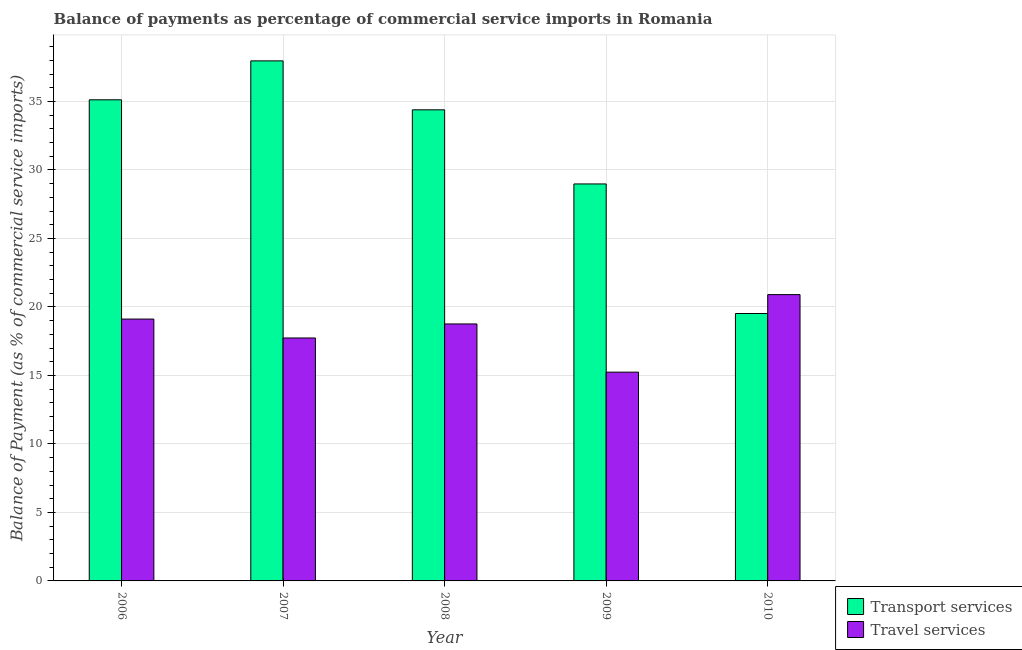How many different coloured bars are there?
Provide a succinct answer. 2. Are the number of bars per tick equal to the number of legend labels?
Provide a succinct answer. Yes. How many bars are there on the 1st tick from the right?
Your answer should be very brief. 2. What is the balance of payments of travel services in 2006?
Give a very brief answer. 19.11. Across all years, what is the maximum balance of payments of transport services?
Your answer should be very brief. 37.96. Across all years, what is the minimum balance of payments of travel services?
Your answer should be very brief. 15.24. In which year was the balance of payments of transport services maximum?
Ensure brevity in your answer.  2007. What is the total balance of payments of transport services in the graph?
Your response must be concise. 155.97. What is the difference between the balance of payments of travel services in 2006 and that in 2008?
Provide a succinct answer. 0.36. What is the difference between the balance of payments of travel services in 2006 and the balance of payments of transport services in 2008?
Your answer should be very brief. 0.36. What is the average balance of payments of travel services per year?
Offer a very short reply. 18.35. What is the ratio of the balance of payments of travel services in 2006 to that in 2009?
Offer a very short reply. 1.25. Is the balance of payments of transport services in 2006 less than that in 2009?
Provide a succinct answer. No. What is the difference between the highest and the second highest balance of payments of transport services?
Offer a terse response. 2.84. What is the difference between the highest and the lowest balance of payments of travel services?
Your answer should be very brief. 5.66. Is the sum of the balance of payments of travel services in 2008 and 2010 greater than the maximum balance of payments of transport services across all years?
Ensure brevity in your answer.  Yes. What does the 2nd bar from the left in 2006 represents?
Your response must be concise. Travel services. What does the 2nd bar from the right in 2009 represents?
Provide a short and direct response. Transport services. How many bars are there?
Your response must be concise. 10. How many years are there in the graph?
Your answer should be very brief. 5. Are the values on the major ticks of Y-axis written in scientific E-notation?
Your answer should be very brief. No. Does the graph contain grids?
Provide a succinct answer. Yes. Where does the legend appear in the graph?
Provide a short and direct response. Bottom right. What is the title of the graph?
Give a very brief answer. Balance of payments as percentage of commercial service imports in Romania. What is the label or title of the Y-axis?
Offer a very short reply. Balance of Payment (as % of commercial service imports). What is the Balance of Payment (as % of commercial service imports) in Transport services in 2006?
Make the answer very short. 35.12. What is the Balance of Payment (as % of commercial service imports) of Travel services in 2006?
Ensure brevity in your answer.  19.11. What is the Balance of Payment (as % of commercial service imports) in Transport services in 2007?
Your response must be concise. 37.96. What is the Balance of Payment (as % of commercial service imports) in Travel services in 2007?
Make the answer very short. 17.73. What is the Balance of Payment (as % of commercial service imports) in Transport services in 2008?
Make the answer very short. 34.39. What is the Balance of Payment (as % of commercial service imports) in Travel services in 2008?
Make the answer very short. 18.76. What is the Balance of Payment (as % of commercial service imports) of Transport services in 2009?
Offer a very short reply. 28.98. What is the Balance of Payment (as % of commercial service imports) of Travel services in 2009?
Give a very brief answer. 15.24. What is the Balance of Payment (as % of commercial service imports) in Transport services in 2010?
Give a very brief answer. 19.52. What is the Balance of Payment (as % of commercial service imports) in Travel services in 2010?
Keep it short and to the point. 20.9. Across all years, what is the maximum Balance of Payment (as % of commercial service imports) in Transport services?
Keep it short and to the point. 37.96. Across all years, what is the maximum Balance of Payment (as % of commercial service imports) of Travel services?
Give a very brief answer. 20.9. Across all years, what is the minimum Balance of Payment (as % of commercial service imports) in Transport services?
Your answer should be very brief. 19.52. Across all years, what is the minimum Balance of Payment (as % of commercial service imports) of Travel services?
Your response must be concise. 15.24. What is the total Balance of Payment (as % of commercial service imports) of Transport services in the graph?
Make the answer very short. 155.97. What is the total Balance of Payment (as % of commercial service imports) in Travel services in the graph?
Provide a succinct answer. 91.75. What is the difference between the Balance of Payment (as % of commercial service imports) in Transport services in 2006 and that in 2007?
Offer a terse response. -2.84. What is the difference between the Balance of Payment (as % of commercial service imports) of Travel services in 2006 and that in 2007?
Provide a succinct answer. 1.38. What is the difference between the Balance of Payment (as % of commercial service imports) in Transport services in 2006 and that in 2008?
Your answer should be very brief. 0.73. What is the difference between the Balance of Payment (as % of commercial service imports) in Travel services in 2006 and that in 2008?
Offer a very short reply. 0.36. What is the difference between the Balance of Payment (as % of commercial service imports) in Transport services in 2006 and that in 2009?
Offer a very short reply. 6.14. What is the difference between the Balance of Payment (as % of commercial service imports) in Travel services in 2006 and that in 2009?
Provide a short and direct response. 3.87. What is the difference between the Balance of Payment (as % of commercial service imports) in Transport services in 2006 and that in 2010?
Offer a very short reply. 15.6. What is the difference between the Balance of Payment (as % of commercial service imports) of Travel services in 2006 and that in 2010?
Offer a terse response. -1.79. What is the difference between the Balance of Payment (as % of commercial service imports) in Transport services in 2007 and that in 2008?
Provide a short and direct response. 3.57. What is the difference between the Balance of Payment (as % of commercial service imports) in Travel services in 2007 and that in 2008?
Provide a succinct answer. -1.02. What is the difference between the Balance of Payment (as % of commercial service imports) of Transport services in 2007 and that in 2009?
Provide a succinct answer. 8.98. What is the difference between the Balance of Payment (as % of commercial service imports) of Travel services in 2007 and that in 2009?
Your answer should be compact. 2.49. What is the difference between the Balance of Payment (as % of commercial service imports) in Transport services in 2007 and that in 2010?
Keep it short and to the point. 18.44. What is the difference between the Balance of Payment (as % of commercial service imports) of Travel services in 2007 and that in 2010?
Keep it short and to the point. -3.17. What is the difference between the Balance of Payment (as % of commercial service imports) of Transport services in 2008 and that in 2009?
Make the answer very short. 5.41. What is the difference between the Balance of Payment (as % of commercial service imports) in Travel services in 2008 and that in 2009?
Offer a very short reply. 3.52. What is the difference between the Balance of Payment (as % of commercial service imports) of Transport services in 2008 and that in 2010?
Offer a very short reply. 14.87. What is the difference between the Balance of Payment (as % of commercial service imports) in Travel services in 2008 and that in 2010?
Ensure brevity in your answer.  -2.14. What is the difference between the Balance of Payment (as % of commercial service imports) of Transport services in 2009 and that in 2010?
Your answer should be compact. 9.46. What is the difference between the Balance of Payment (as % of commercial service imports) in Travel services in 2009 and that in 2010?
Provide a succinct answer. -5.66. What is the difference between the Balance of Payment (as % of commercial service imports) of Transport services in 2006 and the Balance of Payment (as % of commercial service imports) of Travel services in 2007?
Ensure brevity in your answer.  17.39. What is the difference between the Balance of Payment (as % of commercial service imports) in Transport services in 2006 and the Balance of Payment (as % of commercial service imports) in Travel services in 2008?
Offer a terse response. 16.36. What is the difference between the Balance of Payment (as % of commercial service imports) in Transport services in 2006 and the Balance of Payment (as % of commercial service imports) in Travel services in 2009?
Offer a terse response. 19.88. What is the difference between the Balance of Payment (as % of commercial service imports) in Transport services in 2006 and the Balance of Payment (as % of commercial service imports) in Travel services in 2010?
Ensure brevity in your answer.  14.22. What is the difference between the Balance of Payment (as % of commercial service imports) of Transport services in 2007 and the Balance of Payment (as % of commercial service imports) of Travel services in 2008?
Provide a succinct answer. 19.2. What is the difference between the Balance of Payment (as % of commercial service imports) of Transport services in 2007 and the Balance of Payment (as % of commercial service imports) of Travel services in 2009?
Keep it short and to the point. 22.72. What is the difference between the Balance of Payment (as % of commercial service imports) in Transport services in 2007 and the Balance of Payment (as % of commercial service imports) in Travel services in 2010?
Your response must be concise. 17.06. What is the difference between the Balance of Payment (as % of commercial service imports) in Transport services in 2008 and the Balance of Payment (as % of commercial service imports) in Travel services in 2009?
Keep it short and to the point. 19.15. What is the difference between the Balance of Payment (as % of commercial service imports) of Transport services in 2008 and the Balance of Payment (as % of commercial service imports) of Travel services in 2010?
Your answer should be compact. 13.49. What is the difference between the Balance of Payment (as % of commercial service imports) of Transport services in 2009 and the Balance of Payment (as % of commercial service imports) of Travel services in 2010?
Give a very brief answer. 8.08. What is the average Balance of Payment (as % of commercial service imports) of Transport services per year?
Offer a terse response. 31.19. What is the average Balance of Payment (as % of commercial service imports) in Travel services per year?
Your answer should be very brief. 18.35. In the year 2006, what is the difference between the Balance of Payment (as % of commercial service imports) in Transport services and Balance of Payment (as % of commercial service imports) in Travel services?
Offer a terse response. 16.01. In the year 2007, what is the difference between the Balance of Payment (as % of commercial service imports) in Transport services and Balance of Payment (as % of commercial service imports) in Travel services?
Make the answer very short. 20.23. In the year 2008, what is the difference between the Balance of Payment (as % of commercial service imports) in Transport services and Balance of Payment (as % of commercial service imports) in Travel services?
Give a very brief answer. 15.63. In the year 2009, what is the difference between the Balance of Payment (as % of commercial service imports) of Transport services and Balance of Payment (as % of commercial service imports) of Travel services?
Ensure brevity in your answer.  13.74. In the year 2010, what is the difference between the Balance of Payment (as % of commercial service imports) in Transport services and Balance of Payment (as % of commercial service imports) in Travel services?
Give a very brief answer. -1.38. What is the ratio of the Balance of Payment (as % of commercial service imports) of Transport services in 2006 to that in 2007?
Offer a terse response. 0.93. What is the ratio of the Balance of Payment (as % of commercial service imports) in Travel services in 2006 to that in 2007?
Give a very brief answer. 1.08. What is the ratio of the Balance of Payment (as % of commercial service imports) of Transport services in 2006 to that in 2008?
Give a very brief answer. 1.02. What is the ratio of the Balance of Payment (as % of commercial service imports) of Travel services in 2006 to that in 2008?
Ensure brevity in your answer.  1.02. What is the ratio of the Balance of Payment (as % of commercial service imports) in Transport services in 2006 to that in 2009?
Ensure brevity in your answer.  1.21. What is the ratio of the Balance of Payment (as % of commercial service imports) in Travel services in 2006 to that in 2009?
Provide a succinct answer. 1.25. What is the ratio of the Balance of Payment (as % of commercial service imports) of Transport services in 2006 to that in 2010?
Ensure brevity in your answer.  1.8. What is the ratio of the Balance of Payment (as % of commercial service imports) of Travel services in 2006 to that in 2010?
Keep it short and to the point. 0.91. What is the ratio of the Balance of Payment (as % of commercial service imports) of Transport services in 2007 to that in 2008?
Provide a succinct answer. 1.1. What is the ratio of the Balance of Payment (as % of commercial service imports) of Travel services in 2007 to that in 2008?
Make the answer very short. 0.95. What is the ratio of the Balance of Payment (as % of commercial service imports) of Transport services in 2007 to that in 2009?
Offer a terse response. 1.31. What is the ratio of the Balance of Payment (as % of commercial service imports) of Travel services in 2007 to that in 2009?
Make the answer very short. 1.16. What is the ratio of the Balance of Payment (as % of commercial service imports) of Transport services in 2007 to that in 2010?
Provide a succinct answer. 1.94. What is the ratio of the Balance of Payment (as % of commercial service imports) of Travel services in 2007 to that in 2010?
Make the answer very short. 0.85. What is the ratio of the Balance of Payment (as % of commercial service imports) in Transport services in 2008 to that in 2009?
Provide a succinct answer. 1.19. What is the ratio of the Balance of Payment (as % of commercial service imports) in Travel services in 2008 to that in 2009?
Keep it short and to the point. 1.23. What is the ratio of the Balance of Payment (as % of commercial service imports) of Transport services in 2008 to that in 2010?
Offer a terse response. 1.76. What is the ratio of the Balance of Payment (as % of commercial service imports) in Travel services in 2008 to that in 2010?
Make the answer very short. 0.9. What is the ratio of the Balance of Payment (as % of commercial service imports) in Transport services in 2009 to that in 2010?
Provide a succinct answer. 1.48. What is the ratio of the Balance of Payment (as % of commercial service imports) in Travel services in 2009 to that in 2010?
Offer a terse response. 0.73. What is the difference between the highest and the second highest Balance of Payment (as % of commercial service imports) in Transport services?
Make the answer very short. 2.84. What is the difference between the highest and the second highest Balance of Payment (as % of commercial service imports) of Travel services?
Give a very brief answer. 1.79. What is the difference between the highest and the lowest Balance of Payment (as % of commercial service imports) in Transport services?
Your answer should be very brief. 18.44. What is the difference between the highest and the lowest Balance of Payment (as % of commercial service imports) in Travel services?
Offer a terse response. 5.66. 